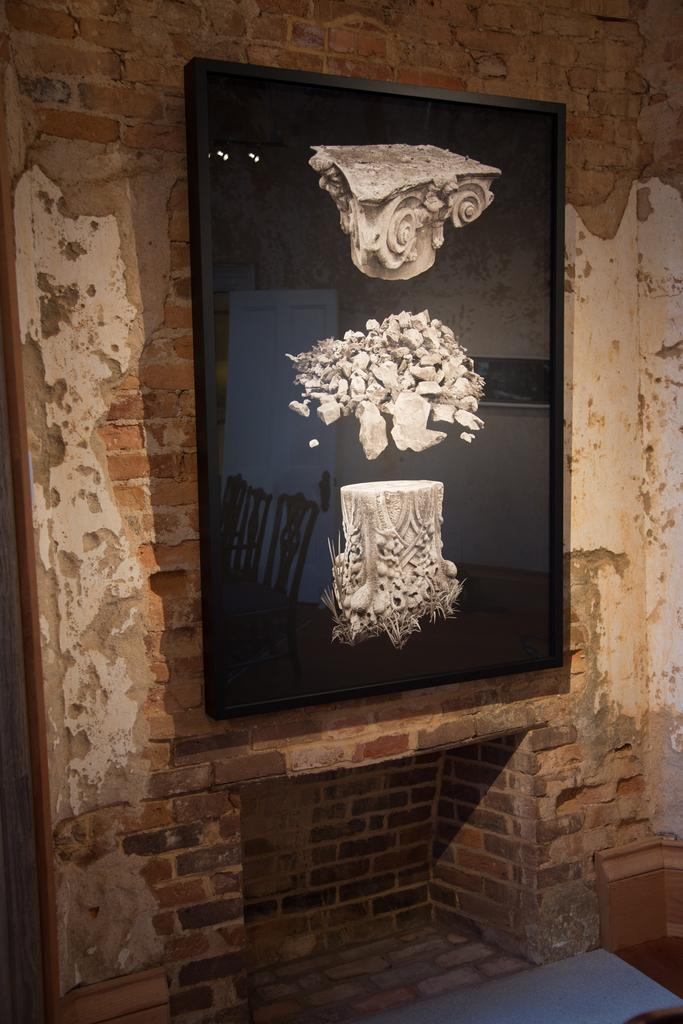What type of structure is visible in the image? There is a brick wall in the image. What is attached to the brick wall? There is a frame on the brick wall. What can be seen on the frame? There are images on the frame. What else can be observed in the image? There are reflections of chairs in the image. Where is the scarecrow positioned in the image? There is no scarecrow present in the image. What type of burn can be seen on the brick wall? There is no burn visible on the brick wall in the image. 